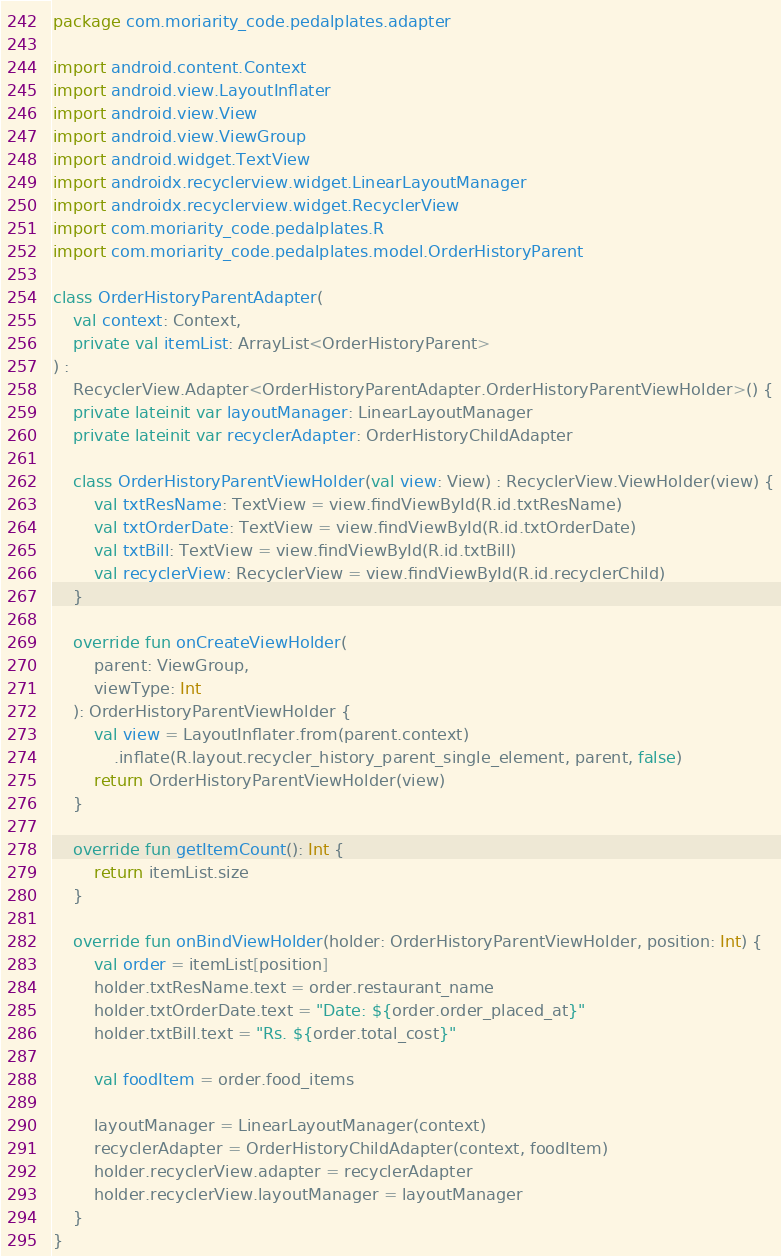<code> <loc_0><loc_0><loc_500><loc_500><_Kotlin_>package com.moriarity_code.pedalplates.adapter

import android.content.Context
import android.view.LayoutInflater
import android.view.View
import android.view.ViewGroup
import android.widget.TextView
import androidx.recyclerview.widget.LinearLayoutManager
import androidx.recyclerview.widget.RecyclerView
import com.moriarity_code.pedalplates.R
import com.moriarity_code.pedalplates.model.OrderHistoryParent

class OrderHistoryParentAdapter(
    val context: Context,
    private val itemList: ArrayList<OrderHistoryParent>
) :
    RecyclerView.Adapter<OrderHistoryParentAdapter.OrderHistoryParentViewHolder>() {
    private lateinit var layoutManager: LinearLayoutManager
    private lateinit var recyclerAdapter: OrderHistoryChildAdapter

    class OrderHistoryParentViewHolder(val view: View) : RecyclerView.ViewHolder(view) {
        val txtResName: TextView = view.findViewById(R.id.txtResName)
        val txtOrderDate: TextView = view.findViewById(R.id.txtOrderDate)
        val txtBill: TextView = view.findViewById(R.id.txtBill)
        val recyclerView: RecyclerView = view.findViewById(R.id.recyclerChild)
    }

    override fun onCreateViewHolder(
        parent: ViewGroup,
        viewType: Int
    ): OrderHistoryParentViewHolder {
        val view = LayoutInflater.from(parent.context)
            .inflate(R.layout.recycler_history_parent_single_element, parent, false)
        return OrderHistoryParentViewHolder(view)
    }

    override fun getItemCount(): Int {
        return itemList.size
    }

    override fun onBindViewHolder(holder: OrderHistoryParentViewHolder, position: Int) {
        val order = itemList[position]
        holder.txtResName.text = order.restaurant_name
        holder.txtOrderDate.text = "Date: ${order.order_placed_at}"
        holder.txtBill.text = "Rs. ${order.total_cost}"

        val foodItem = order.food_items

        layoutManager = LinearLayoutManager(context)
        recyclerAdapter = OrderHistoryChildAdapter(context, foodItem)
        holder.recyclerView.adapter = recyclerAdapter
        holder.recyclerView.layoutManager = layoutManager
    }
}</code> 